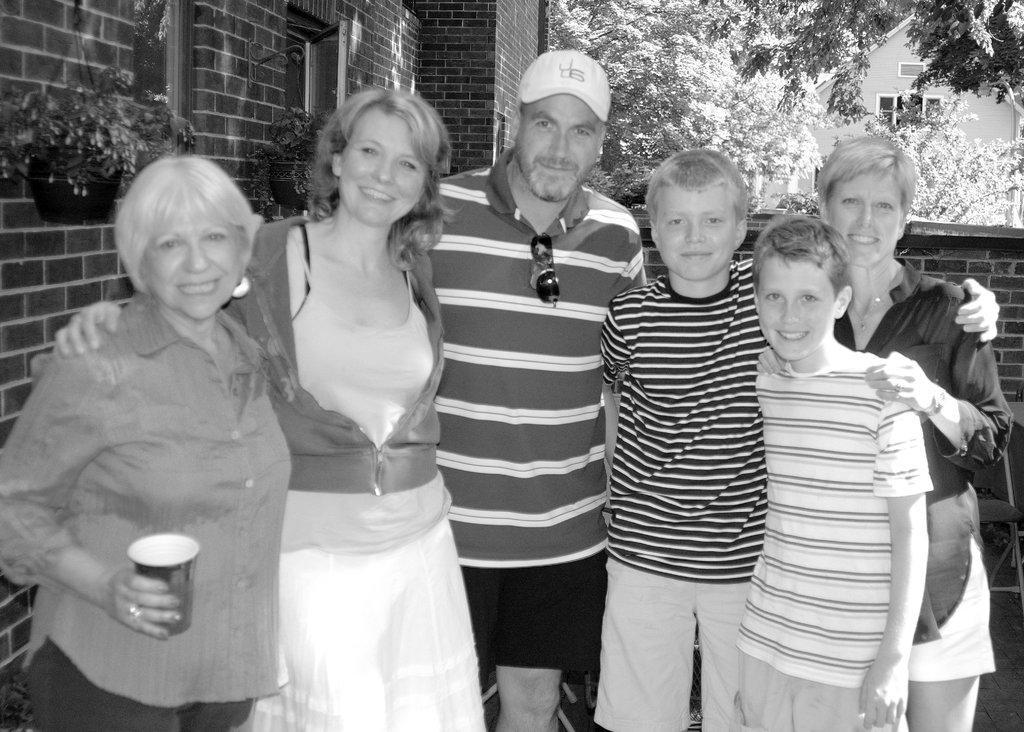Can you describe this image briefly? This is a black and white pic. Here we can see a man,two boys and three women standing and on the left there is a woman holding a cup in her hand. In the background there are trees,houseplants,wall and buildings. 